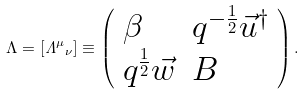Convert formula to latex. <formula><loc_0><loc_0><loc_500><loc_500>\Lambda = [ { { \mathit \Lambda } ^ { \mu } } _ { \nu } ] \equiv \left ( \begin{array} { l l } { \beta } & { { q ^ { - \frac { 1 } { 2 } } \vec { u } ^ { \dagger } } } \\ { { q ^ { \frac { 1 } { 2 } } \vec { w } } } & { B } \end{array} \right ) .</formula> 